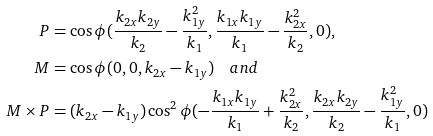<formula> <loc_0><loc_0><loc_500><loc_500>P & = \cos \phi ( \frac { k _ { 2 x } k _ { 2 y } } { k _ { 2 } } - \frac { k _ { 1 y } ^ { 2 } } { k _ { 1 } } , \frac { k _ { 1 x } k _ { 1 y } } { k _ { 1 } } - \frac { k _ { 2 x } ^ { 2 } } { k _ { 2 } } , 0 ) , \\ M & = \cos \phi ( 0 , 0 , k _ { 2 x } - k _ { 1 y } ) \quad a n d \\ M \times P & = ( k _ { 2 x } - k _ { 1 y } ) \cos ^ { 2 } \phi ( - \frac { k _ { 1 x } k _ { 1 y } } { k _ { 1 } } + \frac { k _ { 2 x } ^ { 2 } } { k _ { 2 } } , \frac { k _ { 2 x } k _ { 2 y } } { k _ { 2 } } - \frac { k _ { 1 y } ^ { 2 } } { k _ { 1 } } , 0 )</formula> 